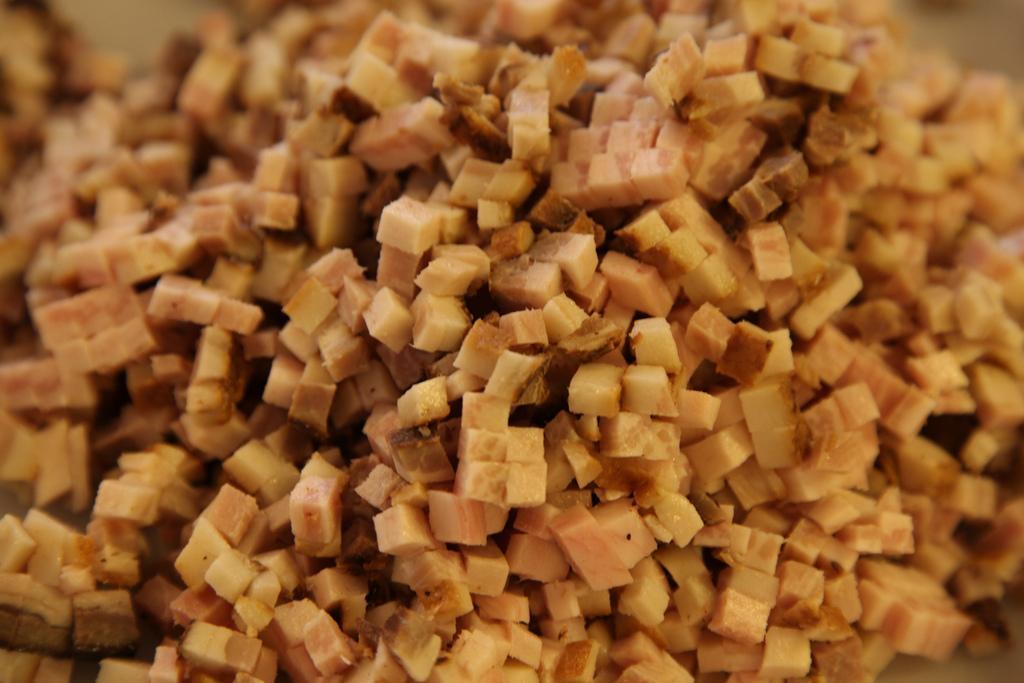Please provide a concise description of this image. In this image, I can see a food item, which is chopped. 